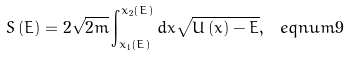<formula> <loc_0><loc_0><loc_500><loc_500>S \left ( E \right ) = 2 \sqrt { 2 m } \int _ { x _ { 1 } \left ( E \right ) } ^ { x _ { 2 } \left ( E \right ) } d x \sqrt { U \left ( x \right ) - E } , \ e q n u m { 9 }</formula> 